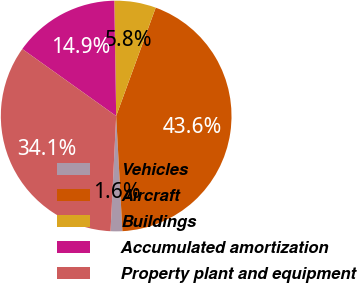Convert chart. <chart><loc_0><loc_0><loc_500><loc_500><pie_chart><fcel>Vehicles<fcel>Aircraft<fcel>Buildings<fcel>Accumulated amortization<fcel>Property plant and equipment<nl><fcel>1.64%<fcel>43.57%<fcel>5.83%<fcel>14.87%<fcel>34.09%<nl></chart> 